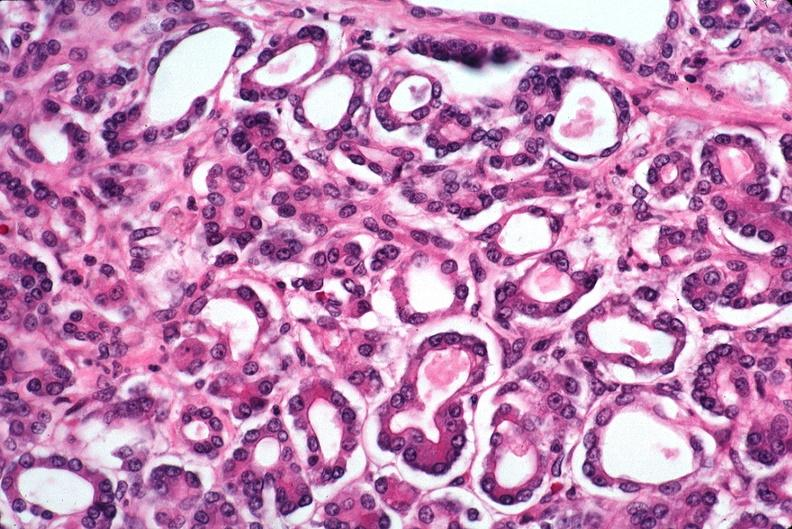why does this image show pancreas, uremic pancreatitis?
Answer the question using a single word or phrase. Due to polycystic kidney 